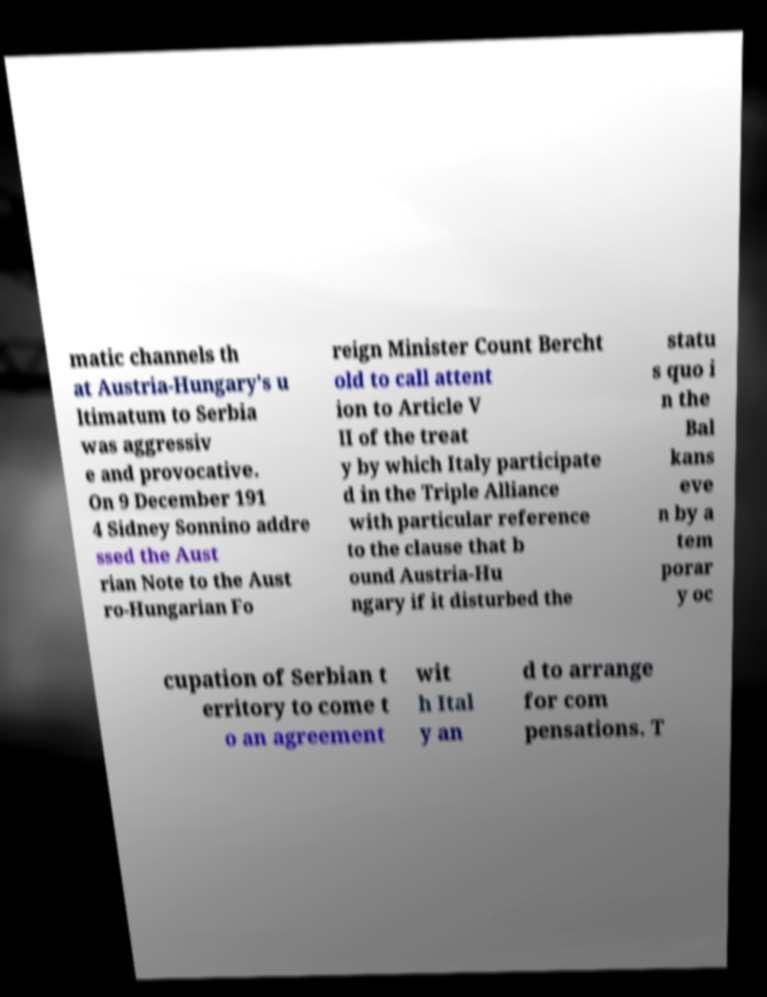For documentation purposes, I need the text within this image transcribed. Could you provide that? matic channels th at Austria-Hungary's u ltimatum to Serbia was aggressiv e and provocative. On 9 December 191 4 Sidney Sonnino addre ssed the Aust rian Note to the Aust ro-Hungarian Fo reign Minister Count Bercht old to call attent ion to Article V II of the treat y by which Italy participate d in the Triple Alliance with particular reference to the clause that b ound Austria-Hu ngary if it disturbed the statu s quo i n the Bal kans eve n by a tem porar y oc cupation of Serbian t erritory to come t o an agreement wit h Ital y an d to arrange for com pensations. T 